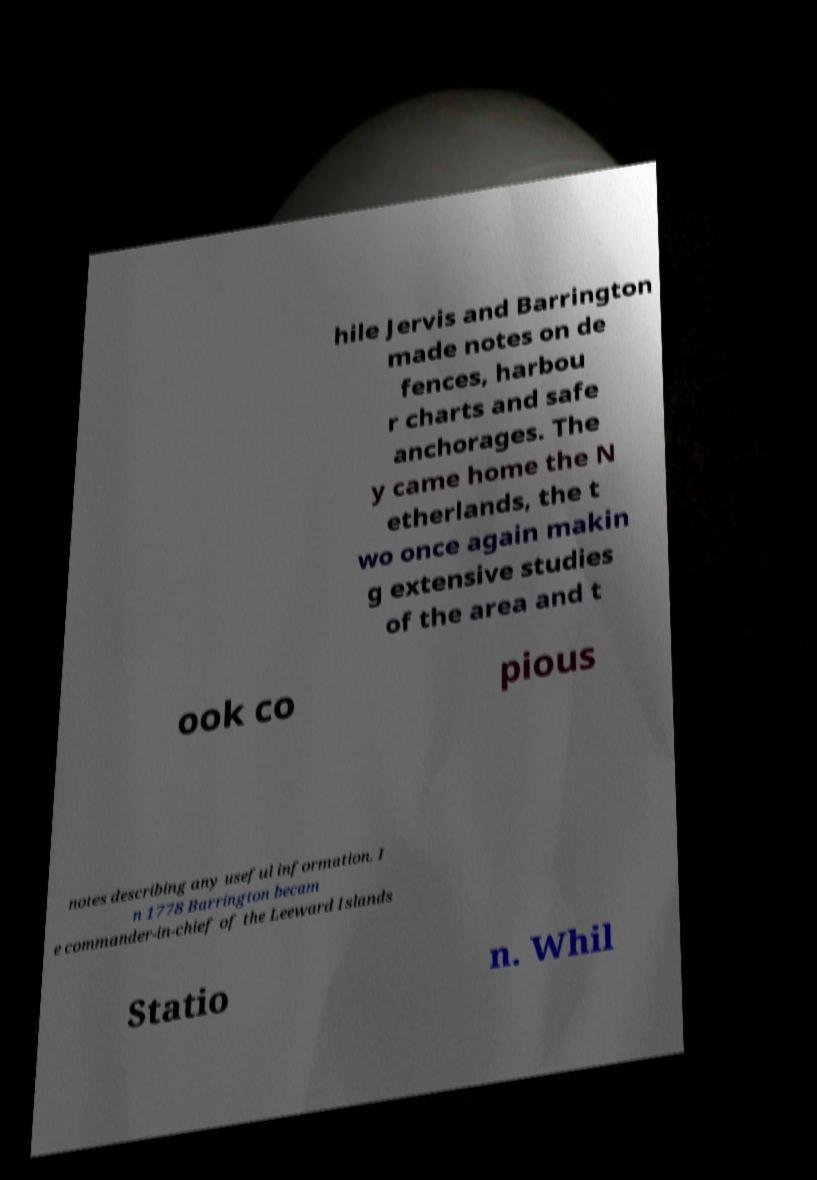Can you read and provide the text displayed in the image?This photo seems to have some interesting text. Can you extract and type it out for me? hile Jervis and Barrington made notes on de fences, harbou r charts and safe anchorages. The y came home the N etherlands, the t wo once again makin g extensive studies of the area and t ook co pious notes describing any useful information. I n 1778 Barrington becam e commander-in-chief of the Leeward Islands Statio n. Whil 